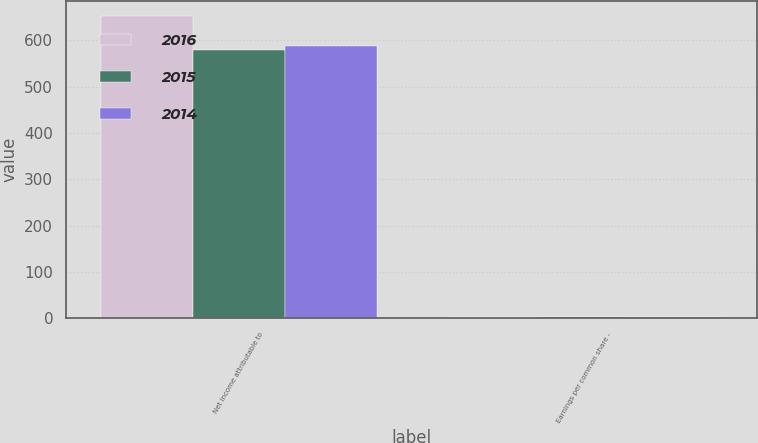Convert chart to OTSL. <chart><loc_0><loc_0><loc_500><loc_500><stacked_bar_chart><ecel><fcel>Net income attributable to<fcel>Earnings per common share -<nl><fcel>2016<fcel>653<fcel>2.68<nl><fcel>2015<fcel>579<fcel>2.38<nl><fcel>2014<fcel>587<fcel>2.4<nl></chart> 